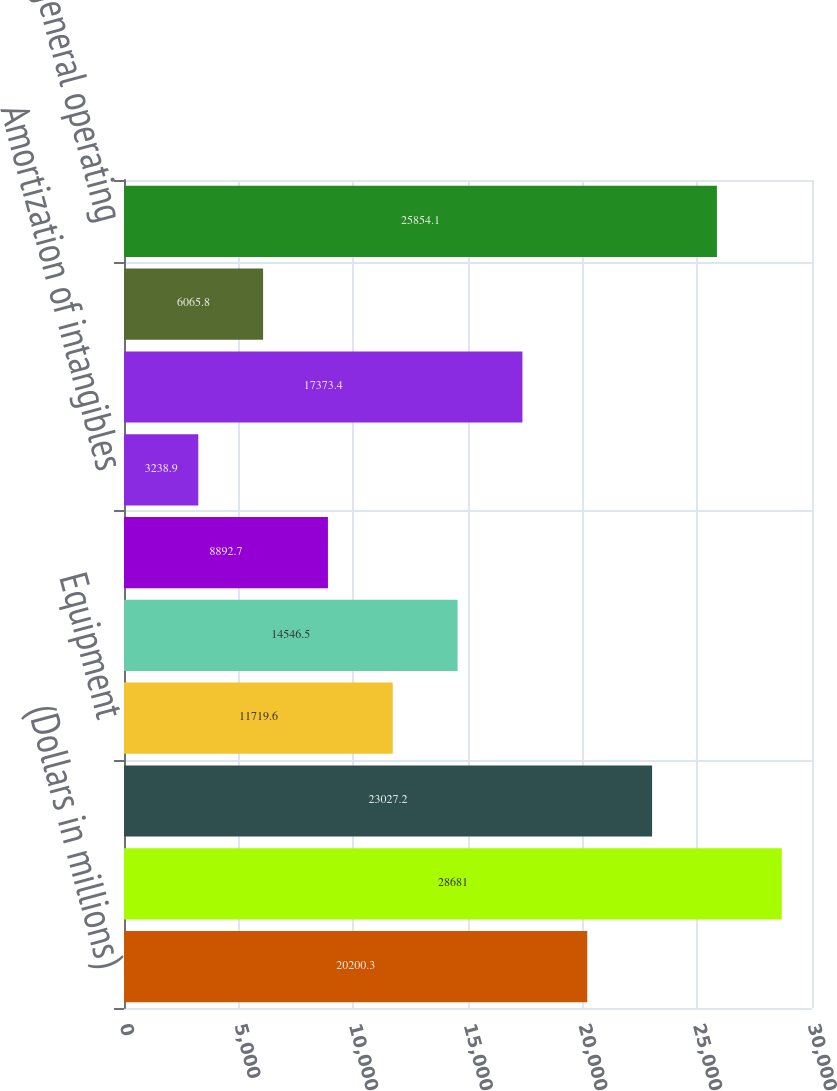Convert chart. <chart><loc_0><loc_0><loc_500><loc_500><bar_chart><fcel>(Dollars in millions)<fcel>Personnel<fcel>Occupancy<fcel>Equipment<fcel>Marketing<fcel>Professional fees<fcel>Amortization of intangibles<fcel>Data processing<fcel>Telecommunications<fcel>Other general operating<nl><fcel>20200.3<fcel>28681<fcel>23027.2<fcel>11719.6<fcel>14546.5<fcel>8892.7<fcel>3238.9<fcel>17373.4<fcel>6065.8<fcel>25854.1<nl></chart> 